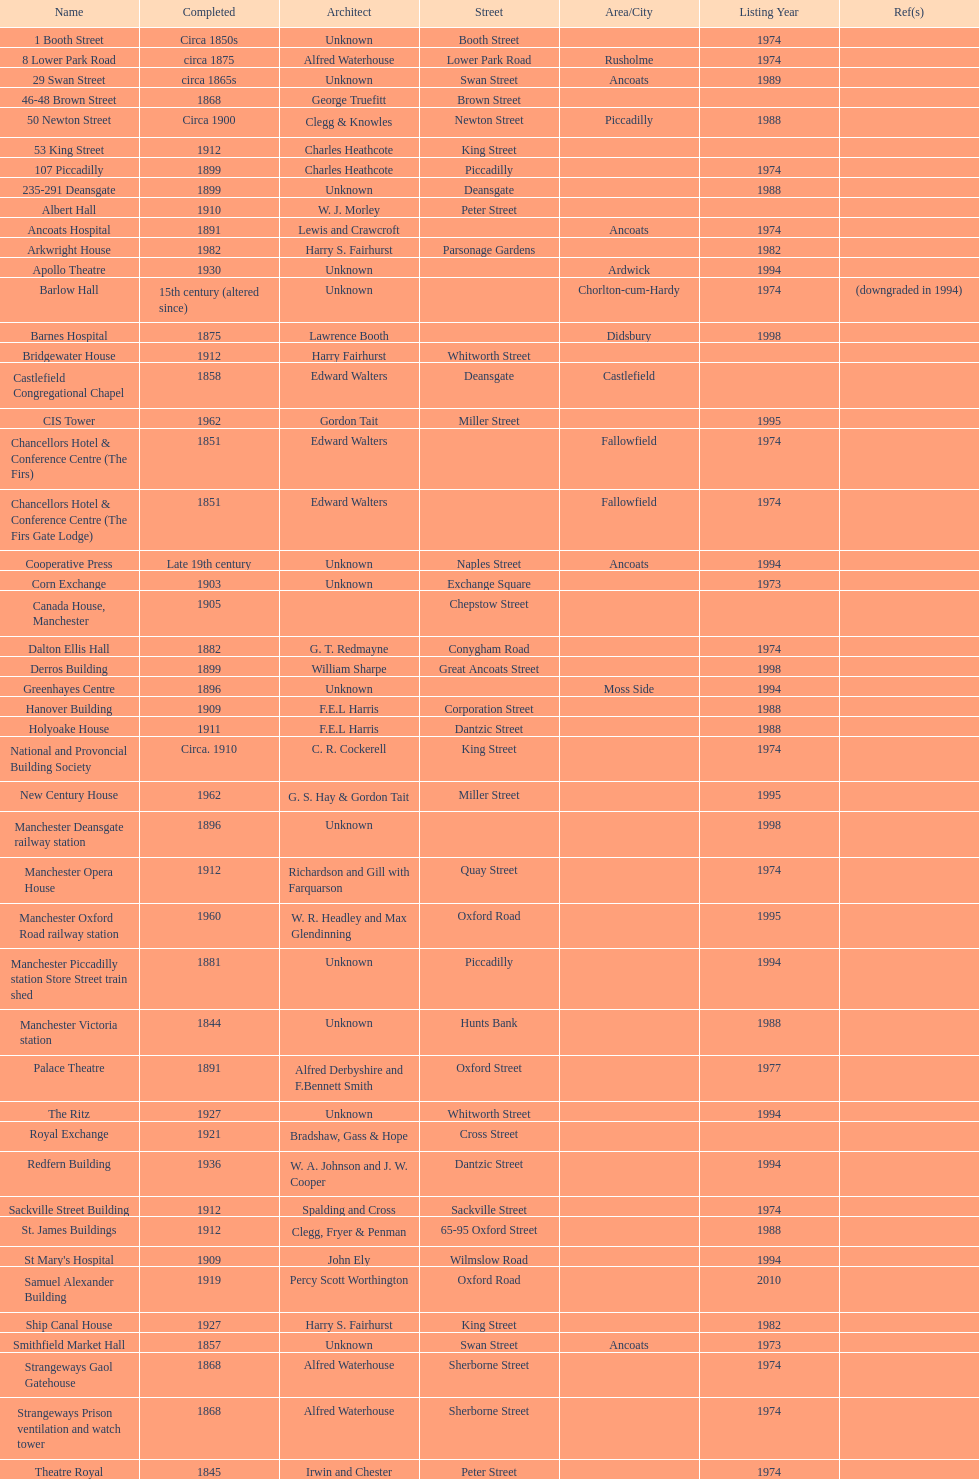Which two buildings were listed before 1974? The Old Wellington Inn, Smithfield Market Hall. 